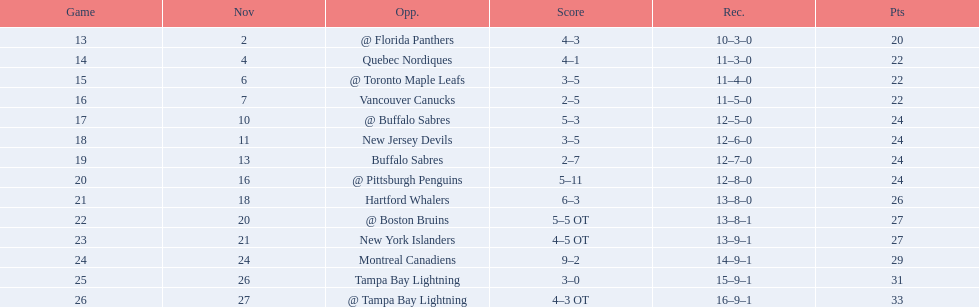What were the scores of the 1993-94 philadelphia flyers season? 4–3, 4–1, 3–5, 2–5, 5–3, 3–5, 2–7, 5–11, 6–3, 5–5 OT, 4–5 OT, 9–2, 3–0, 4–3 OT. Which of these teams had the score 4-5 ot? New York Islanders. 